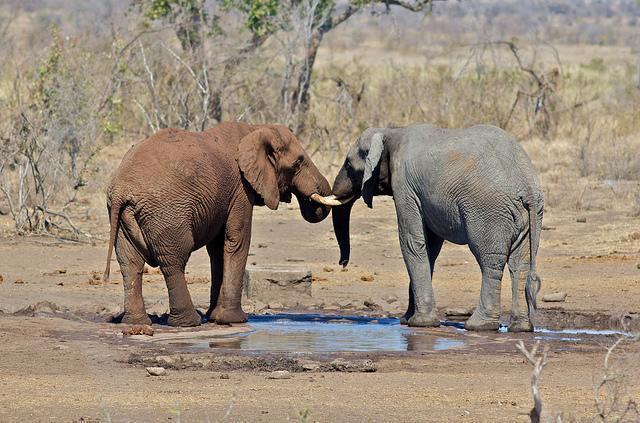How many elephants are in the photo?
Give a very brief answer. 2. 